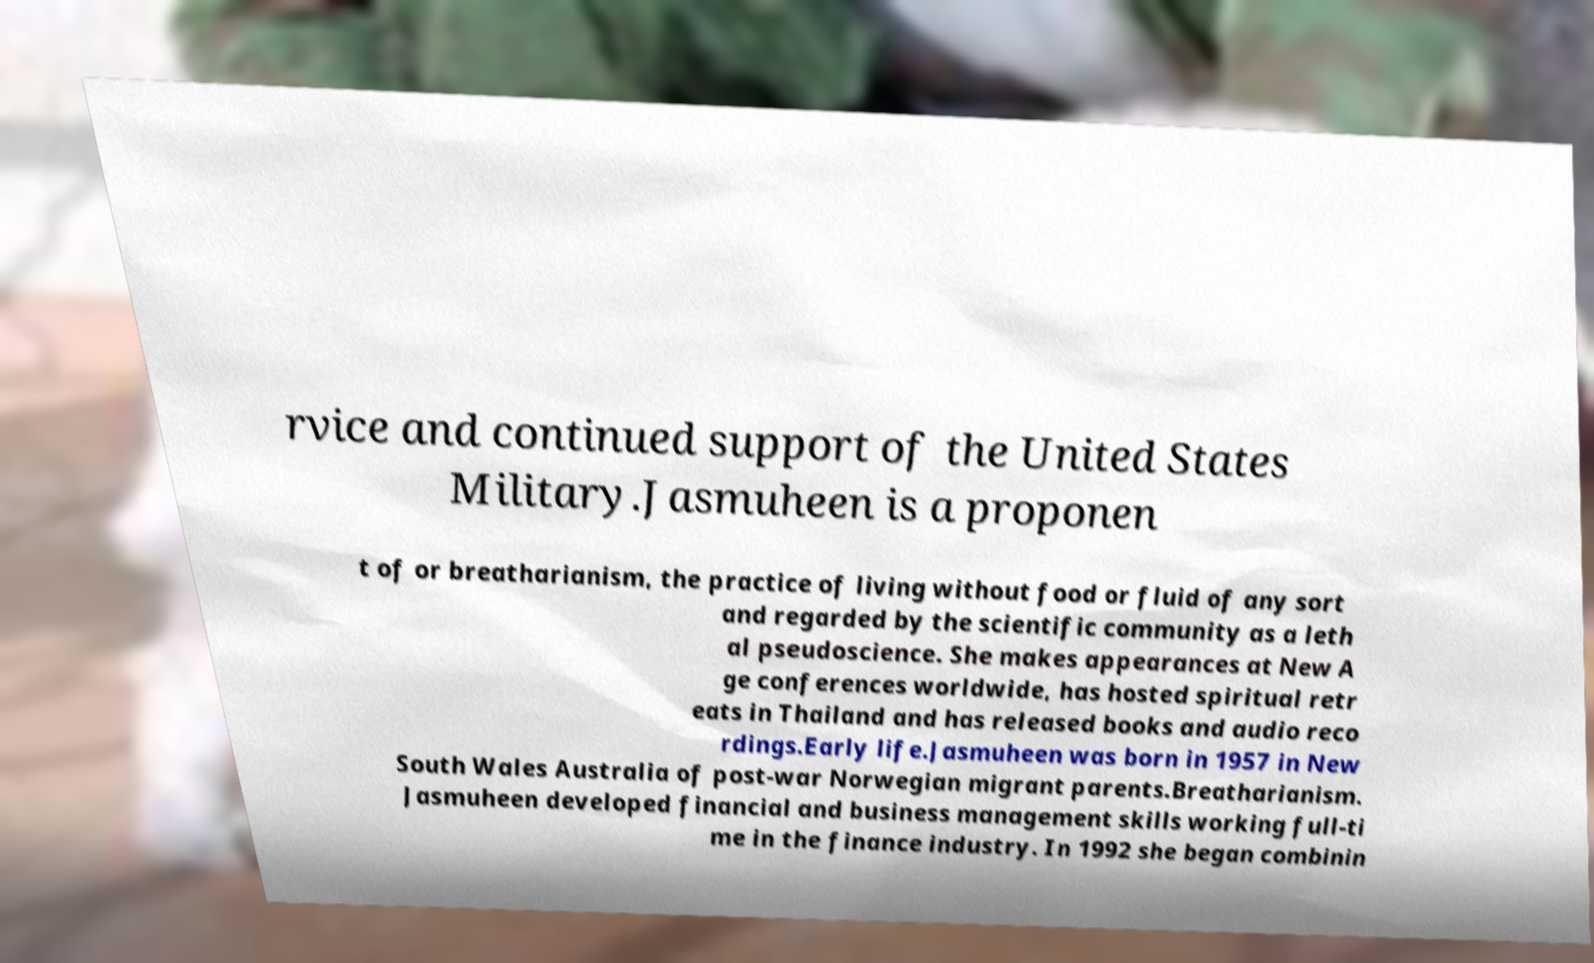Could you extract and type out the text from this image? rvice and continued support of the United States Military.Jasmuheen is a proponen t of or breatharianism, the practice of living without food or fluid of any sort and regarded by the scientific community as a leth al pseudoscience. She makes appearances at New A ge conferences worldwide, has hosted spiritual retr eats in Thailand and has released books and audio reco rdings.Early life.Jasmuheen was born in 1957 in New South Wales Australia of post-war Norwegian migrant parents.Breatharianism. Jasmuheen developed financial and business management skills working full-ti me in the finance industry. In 1992 she began combinin 